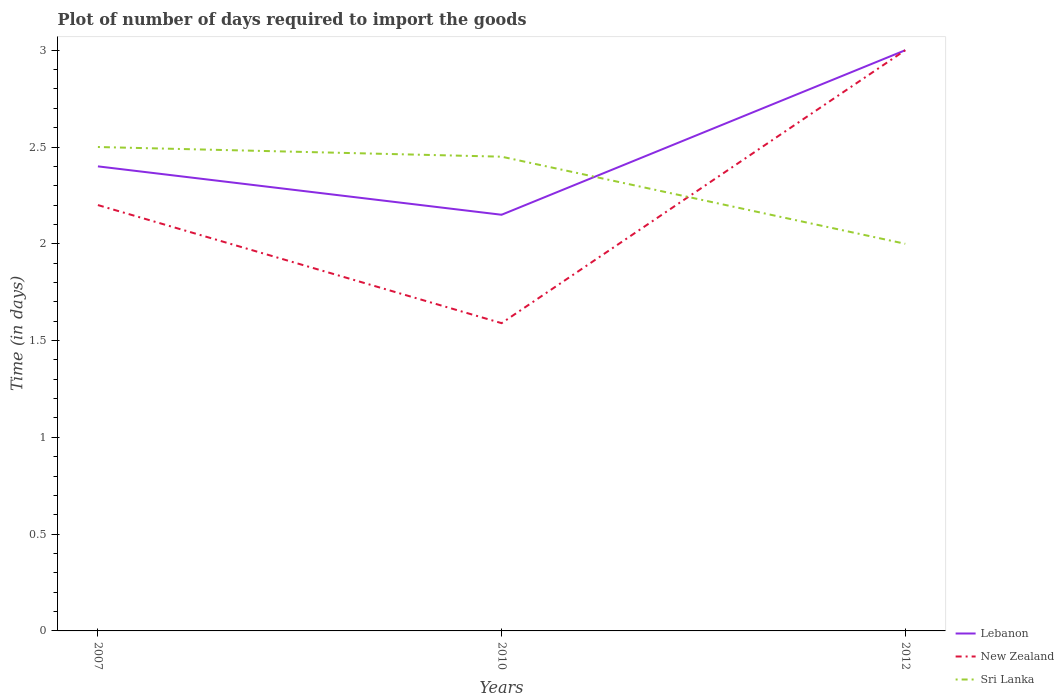Across all years, what is the maximum time required to import goods in New Zealand?
Offer a very short reply. 1.59. In which year was the time required to import goods in New Zealand maximum?
Make the answer very short. 2010. What is the total time required to import goods in Sri Lanka in the graph?
Your answer should be compact. 0.45. What is the difference between the highest and the second highest time required to import goods in Lebanon?
Ensure brevity in your answer.  0.85. What is the difference between the highest and the lowest time required to import goods in New Zealand?
Provide a short and direct response. 1. Is the time required to import goods in New Zealand strictly greater than the time required to import goods in Sri Lanka over the years?
Offer a very short reply. No. How many lines are there?
Keep it short and to the point. 3. What is the difference between two consecutive major ticks on the Y-axis?
Your answer should be very brief. 0.5. Are the values on the major ticks of Y-axis written in scientific E-notation?
Your answer should be very brief. No. How many legend labels are there?
Your response must be concise. 3. How are the legend labels stacked?
Provide a succinct answer. Vertical. What is the title of the graph?
Provide a succinct answer. Plot of number of days required to import the goods. Does "Bahamas" appear as one of the legend labels in the graph?
Ensure brevity in your answer.  No. What is the label or title of the X-axis?
Ensure brevity in your answer.  Years. What is the label or title of the Y-axis?
Give a very brief answer. Time (in days). What is the Time (in days) of New Zealand in 2007?
Offer a terse response. 2.2. What is the Time (in days) in Sri Lanka in 2007?
Make the answer very short. 2.5. What is the Time (in days) in Lebanon in 2010?
Make the answer very short. 2.15. What is the Time (in days) in New Zealand in 2010?
Your answer should be compact. 1.59. What is the Time (in days) of Sri Lanka in 2010?
Ensure brevity in your answer.  2.45. What is the Time (in days) in Lebanon in 2012?
Give a very brief answer. 3. What is the Time (in days) of Sri Lanka in 2012?
Keep it short and to the point. 2. Across all years, what is the maximum Time (in days) in Sri Lanka?
Provide a succinct answer. 2.5. Across all years, what is the minimum Time (in days) in Lebanon?
Offer a terse response. 2.15. Across all years, what is the minimum Time (in days) of New Zealand?
Offer a very short reply. 1.59. Across all years, what is the minimum Time (in days) of Sri Lanka?
Your answer should be very brief. 2. What is the total Time (in days) in Lebanon in the graph?
Give a very brief answer. 7.55. What is the total Time (in days) in New Zealand in the graph?
Give a very brief answer. 6.79. What is the total Time (in days) of Sri Lanka in the graph?
Your response must be concise. 6.95. What is the difference between the Time (in days) of New Zealand in 2007 and that in 2010?
Provide a short and direct response. 0.61. What is the difference between the Time (in days) in Sri Lanka in 2007 and that in 2010?
Provide a short and direct response. 0.05. What is the difference between the Time (in days) of Lebanon in 2007 and that in 2012?
Your answer should be compact. -0.6. What is the difference between the Time (in days) in New Zealand in 2007 and that in 2012?
Provide a short and direct response. -0.8. What is the difference between the Time (in days) of Lebanon in 2010 and that in 2012?
Provide a short and direct response. -0.85. What is the difference between the Time (in days) of New Zealand in 2010 and that in 2012?
Give a very brief answer. -1.41. What is the difference between the Time (in days) of Sri Lanka in 2010 and that in 2012?
Make the answer very short. 0.45. What is the difference between the Time (in days) in Lebanon in 2007 and the Time (in days) in New Zealand in 2010?
Offer a terse response. 0.81. What is the difference between the Time (in days) in Lebanon in 2007 and the Time (in days) in Sri Lanka in 2010?
Keep it short and to the point. -0.05. What is the difference between the Time (in days) of Lebanon in 2007 and the Time (in days) of Sri Lanka in 2012?
Offer a very short reply. 0.4. What is the difference between the Time (in days) of New Zealand in 2007 and the Time (in days) of Sri Lanka in 2012?
Give a very brief answer. 0.2. What is the difference between the Time (in days) of Lebanon in 2010 and the Time (in days) of New Zealand in 2012?
Make the answer very short. -0.85. What is the difference between the Time (in days) of Lebanon in 2010 and the Time (in days) of Sri Lanka in 2012?
Ensure brevity in your answer.  0.15. What is the difference between the Time (in days) of New Zealand in 2010 and the Time (in days) of Sri Lanka in 2012?
Your answer should be compact. -0.41. What is the average Time (in days) in Lebanon per year?
Offer a very short reply. 2.52. What is the average Time (in days) of New Zealand per year?
Your answer should be compact. 2.26. What is the average Time (in days) in Sri Lanka per year?
Keep it short and to the point. 2.32. In the year 2007, what is the difference between the Time (in days) in Lebanon and Time (in days) in New Zealand?
Provide a short and direct response. 0.2. In the year 2010, what is the difference between the Time (in days) of Lebanon and Time (in days) of New Zealand?
Your response must be concise. 0.56. In the year 2010, what is the difference between the Time (in days) in New Zealand and Time (in days) in Sri Lanka?
Make the answer very short. -0.86. In the year 2012, what is the difference between the Time (in days) of Lebanon and Time (in days) of New Zealand?
Offer a very short reply. 0. In the year 2012, what is the difference between the Time (in days) in New Zealand and Time (in days) in Sri Lanka?
Your response must be concise. 1. What is the ratio of the Time (in days) of Lebanon in 2007 to that in 2010?
Ensure brevity in your answer.  1.12. What is the ratio of the Time (in days) in New Zealand in 2007 to that in 2010?
Your response must be concise. 1.38. What is the ratio of the Time (in days) in Sri Lanka in 2007 to that in 2010?
Offer a terse response. 1.02. What is the ratio of the Time (in days) of New Zealand in 2007 to that in 2012?
Ensure brevity in your answer.  0.73. What is the ratio of the Time (in days) in Lebanon in 2010 to that in 2012?
Make the answer very short. 0.72. What is the ratio of the Time (in days) of New Zealand in 2010 to that in 2012?
Ensure brevity in your answer.  0.53. What is the ratio of the Time (in days) of Sri Lanka in 2010 to that in 2012?
Keep it short and to the point. 1.23. What is the difference between the highest and the second highest Time (in days) in Lebanon?
Your answer should be very brief. 0.6. What is the difference between the highest and the second highest Time (in days) of New Zealand?
Keep it short and to the point. 0.8. What is the difference between the highest and the second highest Time (in days) of Sri Lanka?
Offer a very short reply. 0.05. What is the difference between the highest and the lowest Time (in days) of Lebanon?
Provide a short and direct response. 0.85. What is the difference between the highest and the lowest Time (in days) in New Zealand?
Your response must be concise. 1.41. 